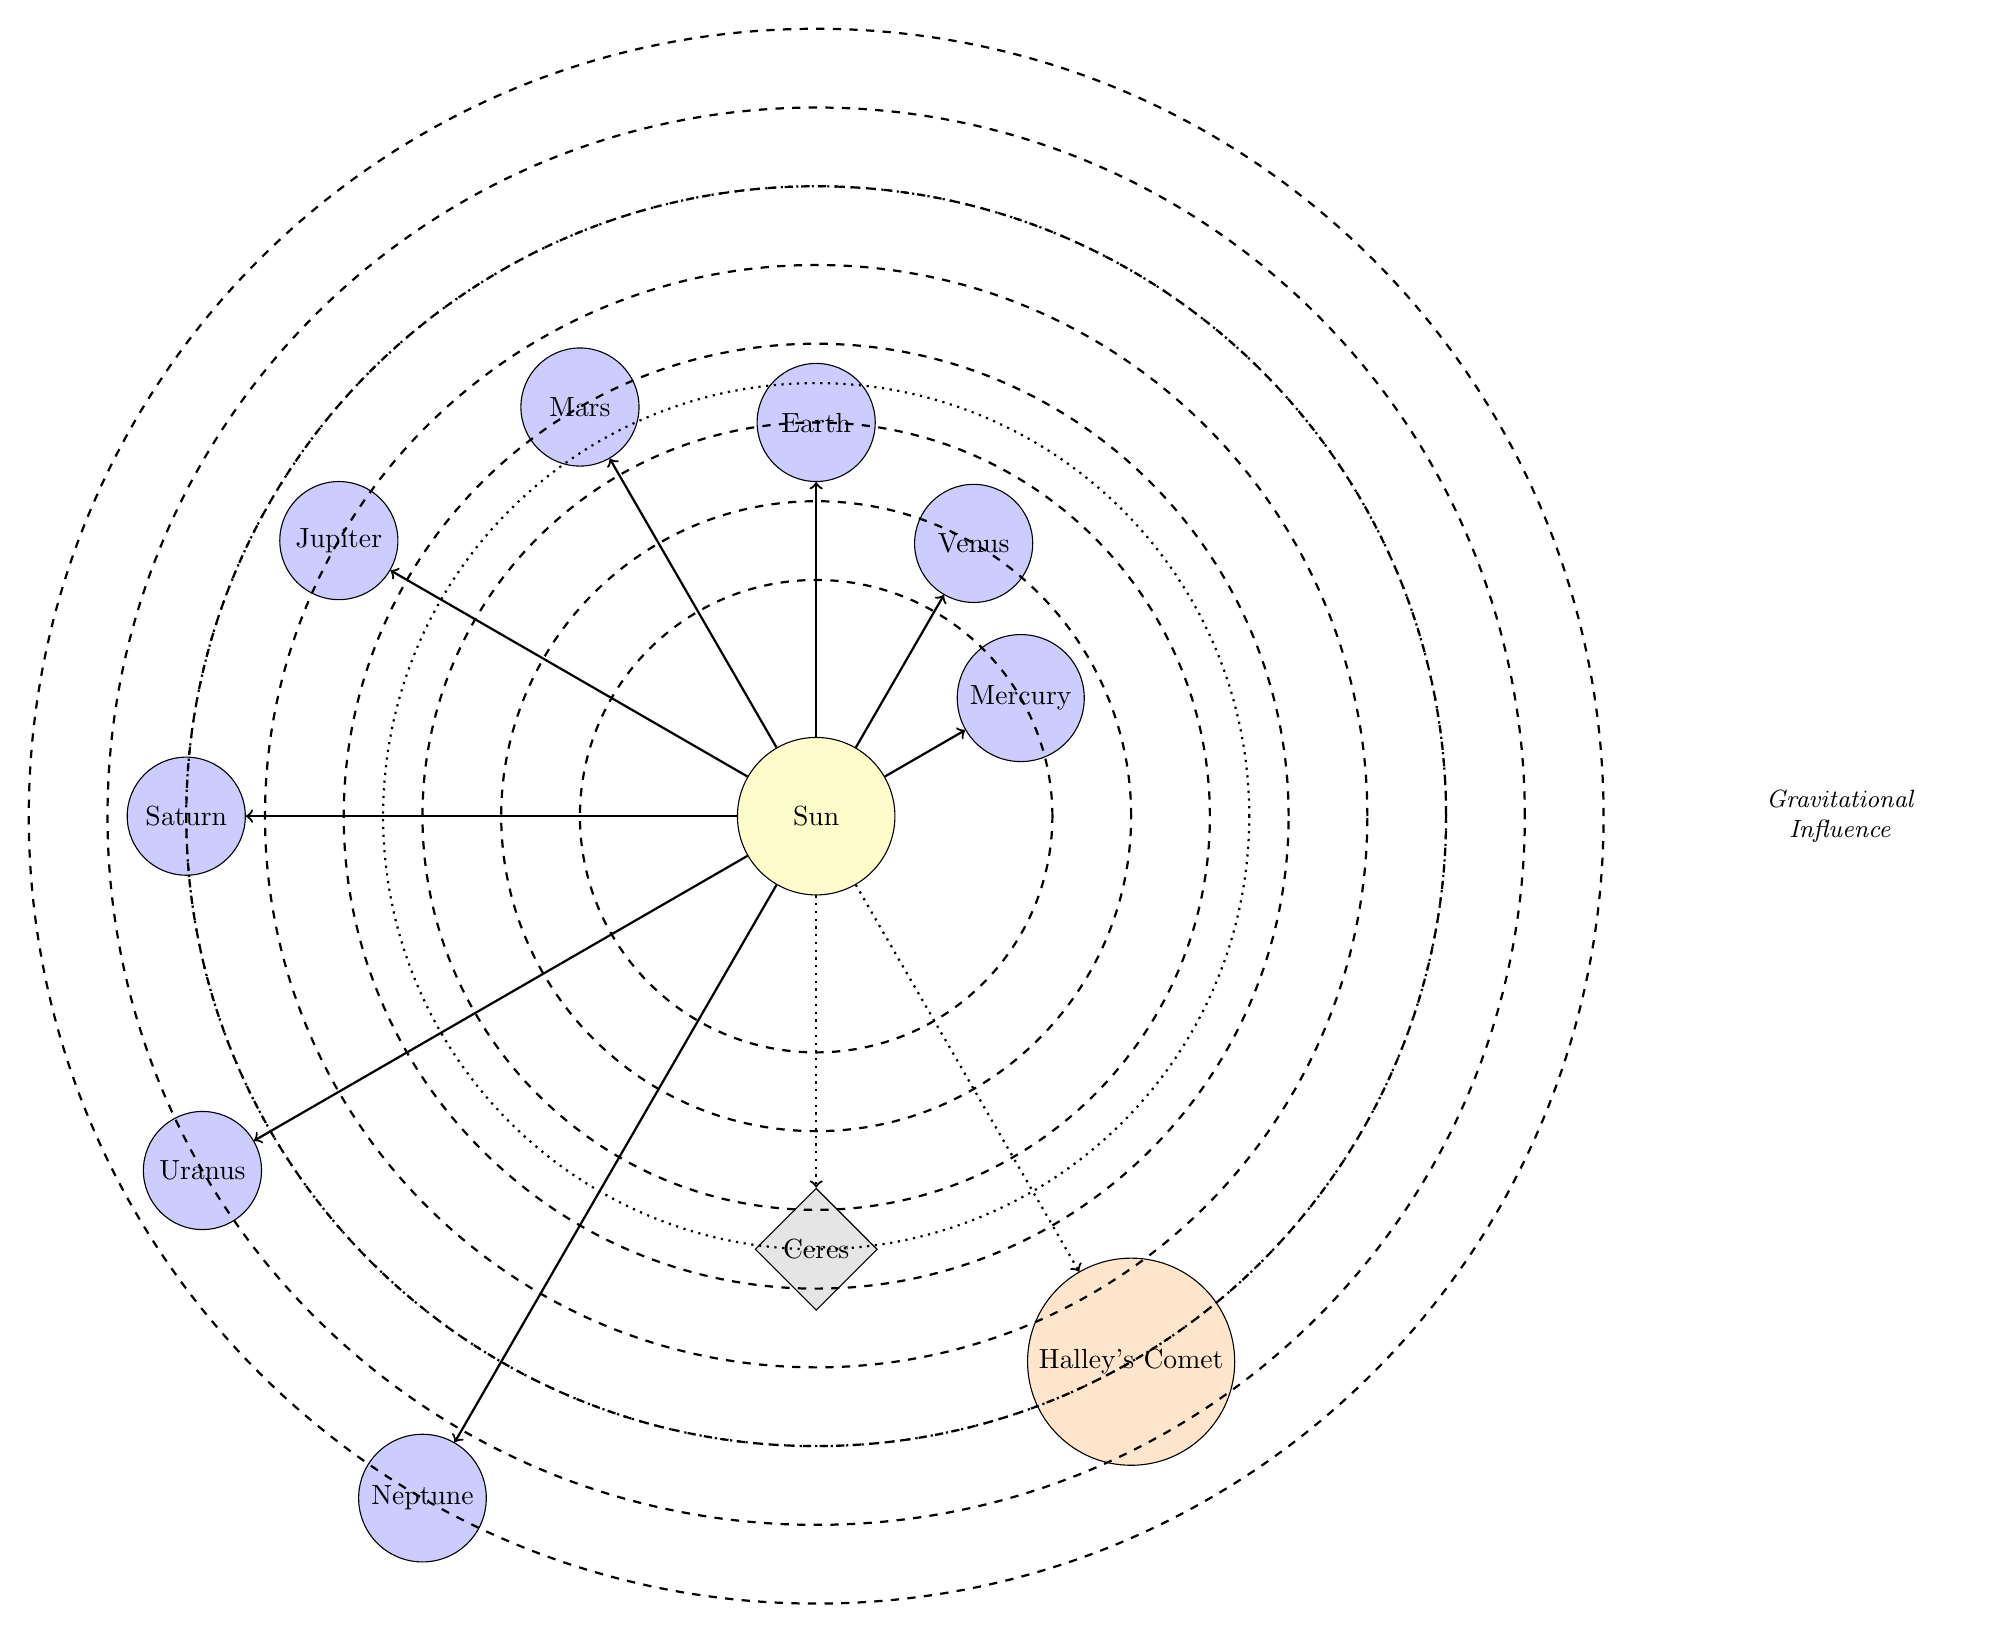What is the gravitational influence acting on Venus? From the diagram, it's clear that the Sun exerts a gravitational influence on Venus, as represented by the directed arrow pointing from the Sun to Venus.
Answer: Sun How many planets are depicted in the diagram? The diagram contains eight distinct planetary nodes represented as blue circles, including Mercury, Venus, Earth, Mars, Jupiter, Saturn, Uranus, and Neptune.
Answer: 8 What is the name of the comet shown in the diagram? The diagram identifies one comet with the label "Halley's Comet," which is illustrated as an orange star shape.
Answer: Halley's Comet Which body is closest to the Sun? By examining the distances indicated on the diagram, Mercury is located at the shortest orbital radius of 3 cm from the Sun, making it the closest celestial body.
Answer: Mercury Which asteroids are shown in the diagram? The diagram includes a single asteroid labeled "Ceres," indicated by a gray diamond shape, identifying the specific celestial feature among the planets.
Answer: Ceres What is the distance from the Sun to Jupiter? The diagram shows Jupiter located at a radial distance of 7 cm from the Sun, which can be determined by the labeled position of the planet within its orbit.
Answer: 7 cm What type of celestial bodies are represented with a dashed orbit? The dashed orbits in the diagram indicate the positions of planets and comets, showing the paths they follow around the Sun, in contrast to solid lines which are standard orbits for major planets.
Answer: Planets and comets Which planet has the furthest orbit from the Sun? Analyzing the diagram reveals that Neptune is the planet situated the farthest from the Sun, with a distance of 10 cm, indicated by its placement at the outermost orbit.
Answer: Neptune How is the gravitational influence on Ceres indicated in the diagram? The influence on Ceres is shown as a dotted arrow connecting it to the Sun, signifying that while the Sun exerts gravitational influence on Ceres, it is less intense compared to the major planets, as represented in the diagram.
Answer: Dotted arrow 